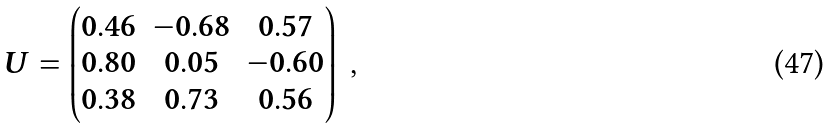Convert formula to latex. <formula><loc_0><loc_0><loc_500><loc_500>U = \left ( \begin{matrix} 0 . 4 6 & - 0 . 6 8 & 0 . 5 7 \\ 0 . 8 0 & 0 . 0 5 & - 0 . 6 0 \\ 0 . 3 8 & 0 . 7 3 & 0 . 5 6 \end{matrix} \right ) \ ,</formula> 